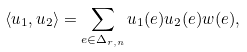Convert formula to latex. <formula><loc_0><loc_0><loc_500><loc_500>\langle u _ { 1 } , u _ { 2 } \rangle = \sum _ { e \in \Delta _ { r , n } } u _ { 1 } ( e ) u _ { 2 } ( e ) w ( e ) ,</formula> 